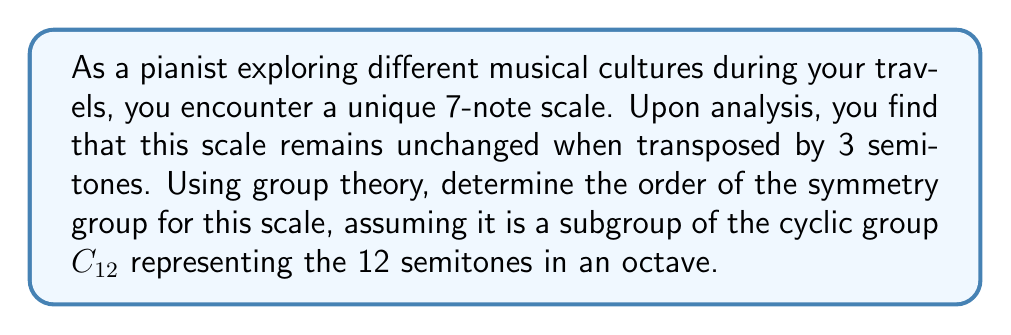Solve this math problem. Let's approach this step-by-step:

1) First, we need to understand what the question is asking. We're dealing with a 7-note scale that has a symmetry when transposed by 3 semitones. This means that the scale is invariant under a rotation of 3 steps in the group $C_{12}$.

2) In group theory terms, we're looking for the order of the subgroup generated by this 3-step rotation.

3) Let's call the generator of this subgroup $g$. We know that $g^4 = e$ (the identity element) because:
   $$g^4 = (3 + 3 + 3 + 3) \mod 12 = 12 \mod 12 = 0$$

4) This means that the subgroup generated by $g$ is cyclic and has order 4. We can represent it as:
   $$\{e, g, g^2, g^3\}$$

5) In musical terms, this means the scale is unchanged when transposed by 0, 3, 6, or 9 semitones.

6) We can verify that these are indeed all the elements of the subgroup:
   $$g^1 = 3 \mod 12 = 3$$
   $$g^2 = 6 \mod 12 = 6$$
   $$g^3 = 9 \mod 12 = 9$$
   $$g^4 = 12 \mod 12 = 0 = e$$

Therefore, the order of the symmetry group for this scale is 4.
Answer: 4 